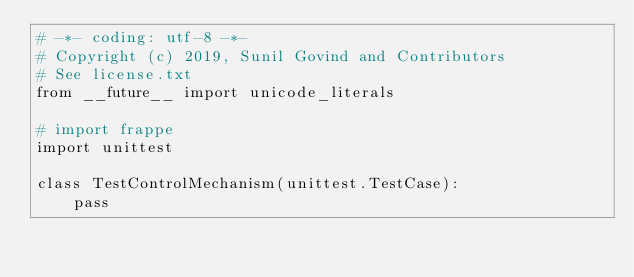Convert code to text. <code><loc_0><loc_0><loc_500><loc_500><_Python_># -*- coding: utf-8 -*-
# Copyright (c) 2019, Sunil Govind and Contributors
# See license.txt
from __future__ import unicode_literals

# import frappe
import unittest

class TestControlMechanism(unittest.TestCase):
	pass
</code> 